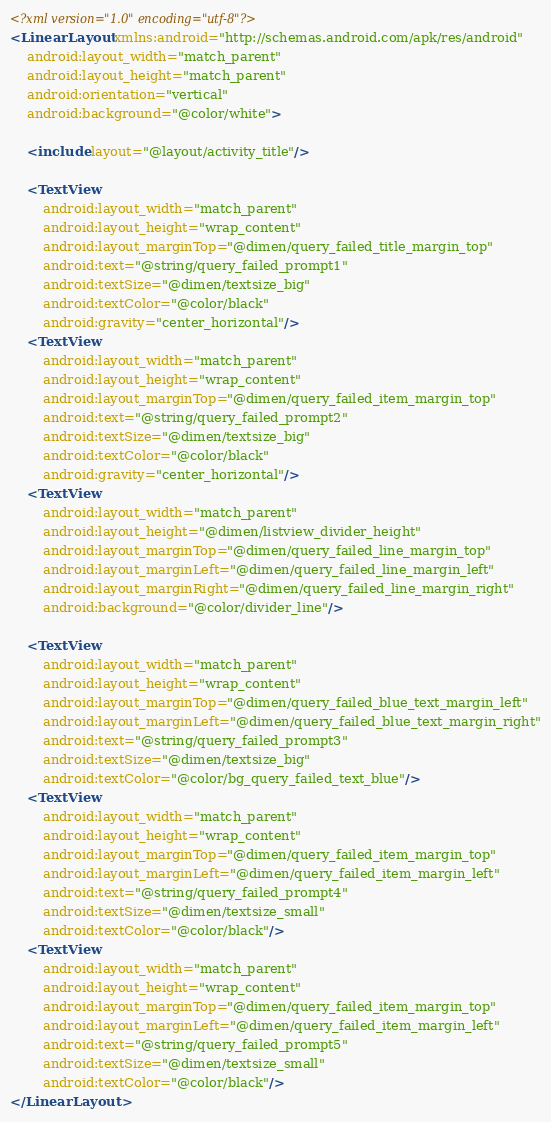Convert code to text. <code><loc_0><loc_0><loc_500><loc_500><_XML_><?xml version="1.0" encoding="utf-8"?>
<LinearLayout xmlns:android="http://schemas.android.com/apk/res/android"
    android:layout_width="match_parent"
    android:layout_height="match_parent"
    android:orientation="vertical"
    android:background="@color/white">
    
    <include layout="@layout/activity_title"/>
    
    <TextView 
        android:layout_width="match_parent"
        android:layout_height="wrap_content"
        android:layout_marginTop="@dimen/query_failed_title_margin_top"
        android:text="@string/query_failed_prompt1"
        android:textSize="@dimen/textsize_big"
        android:textColor="@color/black"
        android:gravity="center_horizontal"/>
    <TextView 
        android:layout_width="match_parent"
        android:layout_height="wrap_content"
        android:layout_marginTop="@dimen/query_failed_item_margin_top"
        android:text="@string/query_failed_prompt2"
        android:textSize="@dimen/textsize_big"
        android:textColor="@color/black"
        android:gravity="center_horizontal"/>
    <TextView
	    android:layout_width="match_parent"
	    android:layout_height="@dimen/listview_divider_height"
	    android:layout_marginTop="@dimen/query_failed_line_margin_top"
	    android:layout_marginLeft="@dimen/query_failed_line_margin_left"
	    android:layout_marginRight="@dimen/query_failed_line_margin_right"
	    android:background="@color/divider_line"/>
    
    <TextView 
        android:layout_width="match_parent"
        android:layout_height="wrap_content"
        android:layout_marginTop="@dimen/query_failed_blue_text_margin_left"
        android:layout_marginLeft="@dimen/query_failed_blue_text_margin_right"
        android:text="@string/query_failed_prompt3"
        android:textSize="@dimen/textsize_big"
        android:textColor="@color/bg_query_failed_text_blue"/>
    <TextView 
        android:layout_width="match_parent"
        android:layout_height="wrap_content"
        android:layout_marginTop="@dimen/query_failed_item_margin_top"
        android:layout_marginLeft="@dimen/query_failed_item_margin_left"
        android:text="@string/query_failed_prompt4"
        android:textSize="@dimen/textsize_small"
        android:textColor="@color/black"/>
    <TextView 
        android:layout_width="match_parent"
        android:layout_height="wrap_content"
        android:layout_marginTop="@dimen/query_failed_item_margin_top"
        android:layout_marginLeft="@dimen/query_failed_item_margin_left"
        android:text="@string/query_failed_prompt5"
        android:textSize="@dimen/textsize_small"
        android:textColor="@color/black"/>
</LinearLayout></code> 